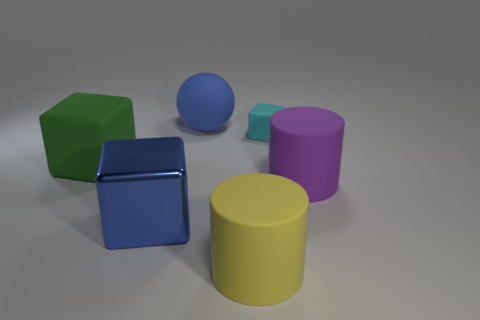If these objects represented elements of a city, could you describe the scene metaphorically? In a metaphorical sense, considering the relative sizes and positions of the objects, the metallic cube could represent a modern, shiny skyscraper that's closest and most prominent in a cityscape. The green and blue cubes could symbolize residential or commercial buildings, while the yellow and purplish-pink cylinders may evoke images of circular plazas or arenas. The blue sphere in the back might be seen as a distant water tower or monument, creating a diverse urban environment. 